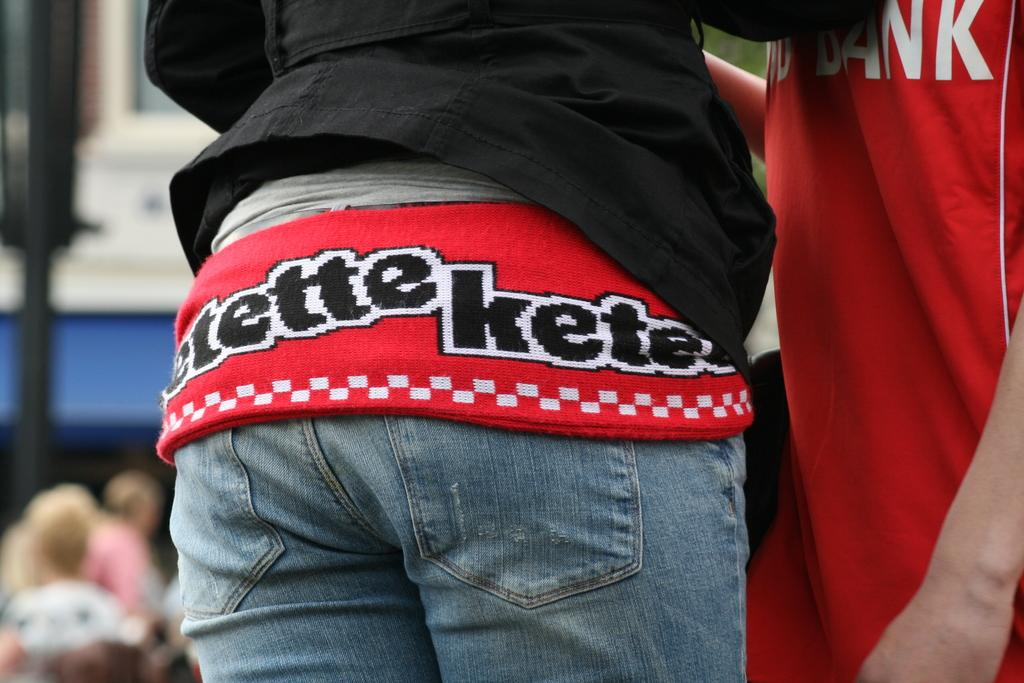<image>
Provide a brief description of the given image. a woman wearing a belt that says 'etette kete' on it 